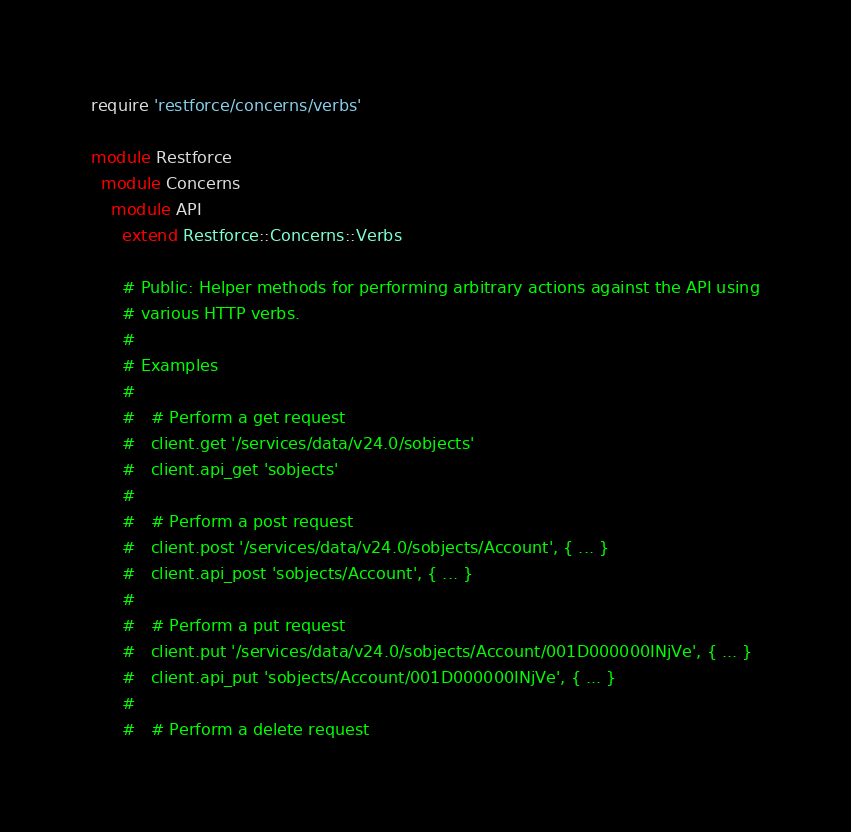<code> <loc_0><loc_0><loc_500><loc_500><_Ruby_>require 'restforce/concerns/verbs'

module Restforce
  module Concerns
    module API
      extend Restforce::Concerns::Verbs

      # Public: Helper methods for performing arbitrary actions against the API using
      # various HTTP verbs.
      #
      # Examples
      #
      #   # Perform a get request
      #   client.get '/services/data/v24.0/sobjects'
      #   client.api_get 'sobjects'
      #
      #   # Perform a post request
      #   client.post '/services/data/v24.0/sobjects/Account', { ... }
      #   client.api_post 'sobjects/Account', { ... }
      #
      #   # Perform a put request
      #   client.put '/services/data/v24.0/sobjects/Account/001D000000INjVe', { ... }
      #   client.api_put 'sobjects/Account/001D000000INjVe', { ... }
      #
      #   # Perform a delete request</code> 